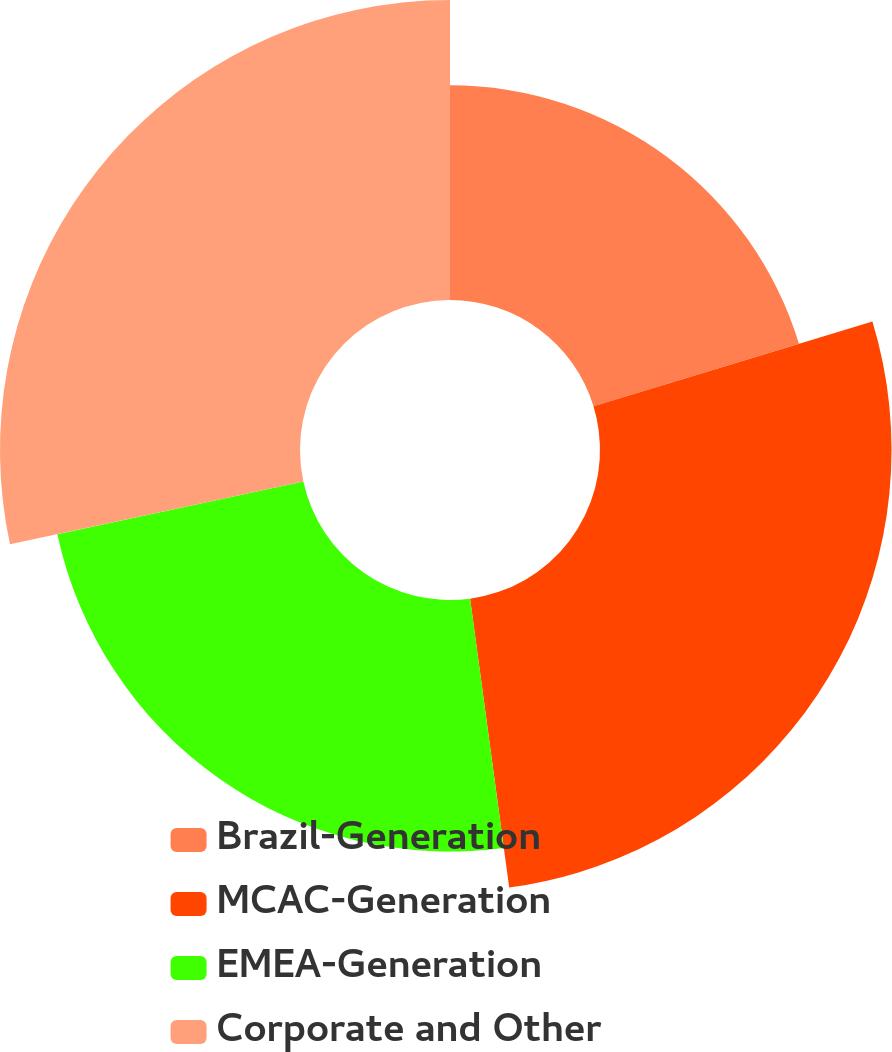Convert chart. <chart><loc_0><loc_0><loc_500><loc_500><pie_chart><fcel>Brazil-Generation<fcel>MCAC-Generation<fcel>EMEA-Generation<fcel>Corporate and Other<nl><fcel>20.3%<fcel>27.56%<fcel>23.78%<fcel>28.36%<nl></chart> 